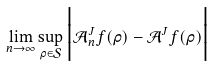<formula> <loc_0><loc_0><loc_500><loc_500>\lim _ { n \rightarrow \infty } \sup _ { \rho \in \mathcal { S } } \Big { | } \mathcal { A } ^ { J } _ { n } f ( \rho ) - \mathcal { A } ^ { J } f ( \rho ) \Big { | }</formula> 